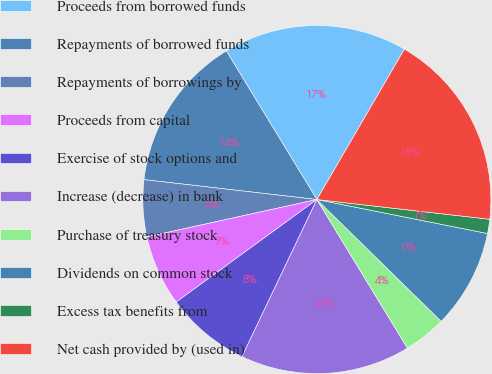Convert chart to OTSL. <chart><loc_0><loc_0><loc_500><loc_500><pie_chart><fcel>Proceeds from borrowed funds<fcel>Repayments of borrowed funds<fcel>Repayments of borrowings by<fcel>Proceeds from capital<fcel>Exercise of stock options and<fcel>Increase (decrease) in bank<fcel>Purchase of treasury stock<fcel>Dividends on common stock<fcel>Excess tax benefits from<fcel>Net cash provided by (used in)<nl><fcel>17.1%<fcel>14.47%<fcel>5.27%<fcel>6.58%<fcel>7.9%<fcel>15.79%<fcel>3.95%<fcel>9.21%<fcel>1.32%<fcel>18.42%<nl></chart> 